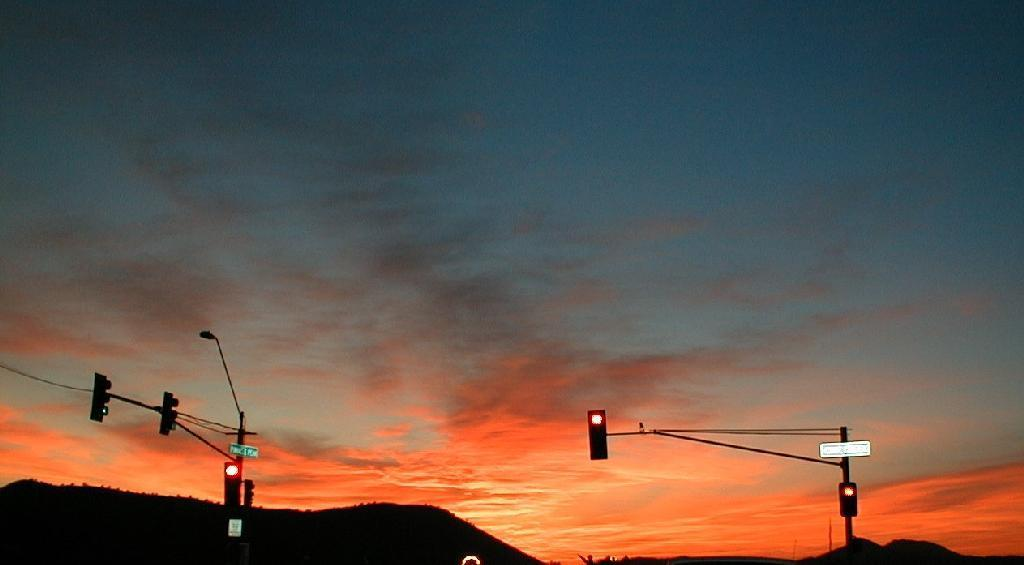What type of signaling device is present in the image? There are traffic lights in the image. How are the traffic lights positioned in the image? The traffic lights are on poles. What geographical feature is visible in the front of the image? There is a mountain in the front of the image. What can be seen in the background of the image? The sky is visible in the background of the image. What atmospheric phenomena are present in the sky? Clouds are present in the sky. What does mom say about the mark on the mountain in the image? There is no mention of a mark on the mountain or a mom in the image, so this question cannot be answered. 